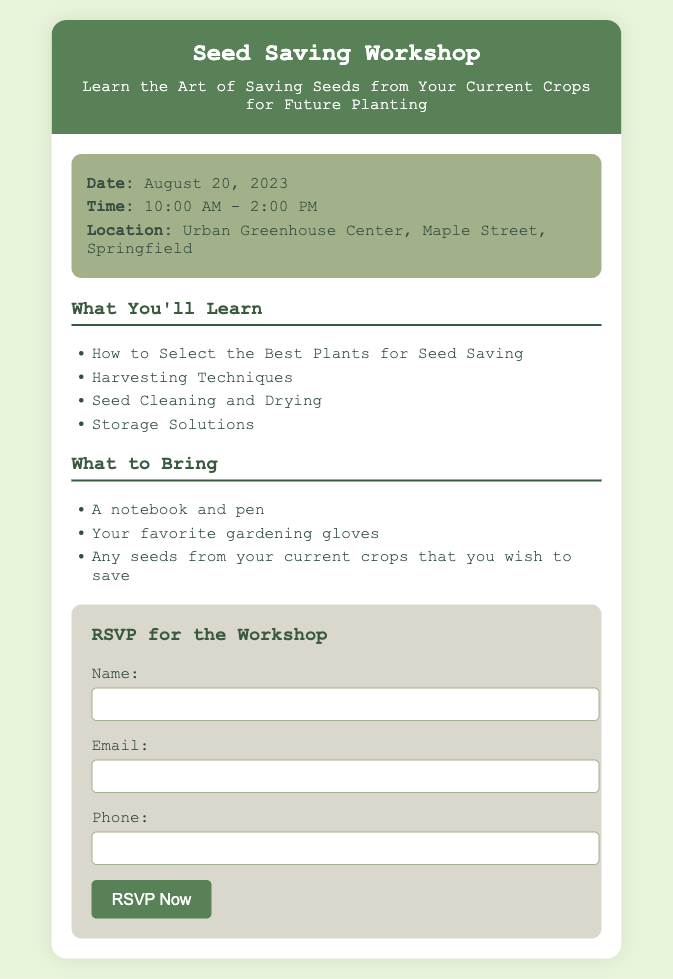what is the date of the workshop? The date of the workshop is explicitly stated in the details section of the document.
Answer: August 20, 2023 what is the location of the workshop? The location is mentioned in the details section of the document.
Answer: Urban Greenhouse Center, Maple Street, Springfield what time does the workshop start? The starting time of the workshop is provided in the details section.
Answer: 10:00 AM how long is the workshop scheduled to last? The duration can be calculated based on the start and end times mentioned in the document.
Answer: 4 hours what should attendees bring to the workshop? The items listed in the "What to Bring" section of the document provide this information.
Answer: A notebook and pen, your favorite gardening gloves, any seeds what skills will be taught at the workshop? The skills to be learned are listed in the "What You'll Learn" section.
Answer: Select the Best Plants for Seed Saving, Harvesting Techniques, Seed Cleaning and Drying, Storage Solutions what is the purpose of the RSVP form? The RSVP form is essential for participants to confirm their attendance at the workshop.
Answer: To confirm attendance how does the workshop benefit gardeners? The workshop provides skills for effective seed saving, beneficial for gardeners wanting to maintain their crops.
Answer: Teaches seed saving skills who is the target audience for the workshop? The wording in the card suggests it aims at anyone interested in gardening, particularly those with urban farms.
Answer: Gardeners, urban farmers 